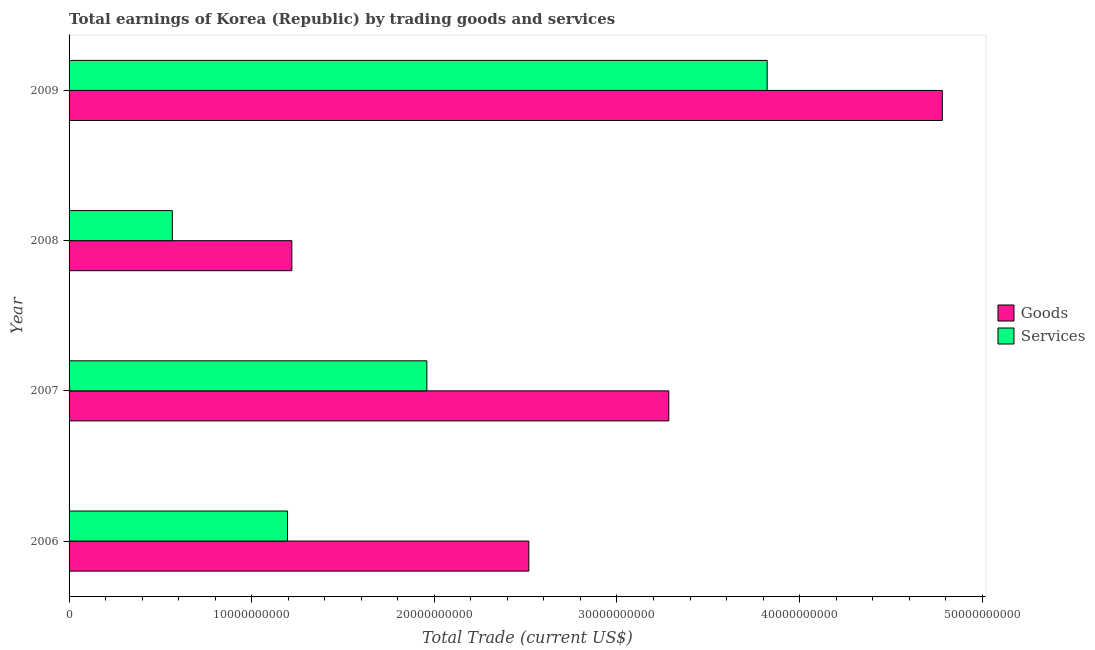How many different coloured bars are there?
Ensure brevity in your answer.  2. Are the number of bars per tick equal to the number of legend labels?
Your response must be concise. Yes. Are the number of bars on each tick of the Y-axis equal?
Keep it short and to the point. Yes. What is the label of the 3rd group of bars from the top?
Offer a very short reply. 2007. What is the amount earned by trading goods in 2009?
Offer a very short reply. 4.78e+1. Across all years, what is the maximum amount earned by trading goods?
Make the answer very short. 4.78e+1. Across all years, what is the minimum amount earned by trading goods?
Your answer should be very brief. 1.22e+1. In which year was the amount earned by trading services minimum?
Keep it short and to the point. 2008. What is the total amount earned by trading goods in the graph?
Your response must be concise. 1.18e+11. What is the difference between the amount earned by trading services in 2006 and that in 2009?
Make the answer very short. -2.63e+1. What is the difference between the amount earned by trading services in 2006 and the amount earned by trading goods in 2007?
Your answer should be compact. -2.09e+1. What is the average amount earned by trading services per year?
Your answer should be very brief. 1.89e+1. In the year 2007, what is the difference between the amount earned by trading services and amount earned by trading goods?
Offer a terse response. -1.32e+1. In how many years, is the amount earned by trading services greater than 18000000000 US$?
Provide a short and direct response. 2. What is the ratio of the amount earned by trading services in 2008 to that in 2009?
Make the answer very short. 0.15. What is the difference between the highest and the second highest amount earned by trading services?
Give a very brief answer. 1.86e+1. What is the difference between the highest and the lowest amount earned by trading services?
Your response must be concise. 3.26e+1. In how many years, is the amount earned by trading goods greater than the average amount earned by trading goods taken over all years?
Provide a short and direct response. 2. What does the 2nd bar from the top in 2006 represents?
Keep it short and to the point. Goods. What does the 2nd bar from the bottom in 2008 represents?
Offer a terse response. Services. How many bars are there?
Your answer should be compact. 8. Are all the bars in the graph horizontal?
Ensure brevity in your answer.  Yes. How many years are there in the graph?
Your answer should be compact. 4. Does the graph contain grids?
Make the answer very short. No. Where does the legend appear in the graph?
Offer a terse response. Center right. What is the title of the graph?
Your answer should be very brief. Total earnings of Korea (Republic) by trading goods and services. Does "Agricultural land" appear as one of the legend labels in the graph?
Make the answer very short. No. What is the label or title of the X-axis?
Your answer should be compact. Total Trade (current US$). What is the Total Trade (current US$) in Goods in 2006?
Make the answer very short. 2.52e+1. What is the Total Trade (current US$) of Services in 2006?
Provide a short and direct response. 1.20e+1. What is the Total Trade (current US$) of Goods in 2007?
Offer a terse response. 3.28e+1. What is the Total Trade (current US$) of Services in 2007?
Keep it short and to the point. 1.96e+1. What is the Total Trade (current US$) in Goods in 2008?
Your answer should be very brief. 1.22e+1. What is the Total Trade (current US$) of Services in 2008?
Make the answer very short. 5.65e+09. What is the Total Trade (current US$) of Goods in 2009?
Offer a terse response. 4.78e+1. What is the Total Trade (current US$) of Services in 2009?
Ensure brevity in your answer.  3.82e+1. Across all years, what is the maximum Total Trade (current US$) of Goods?
Your answer should be compact. 4.78e+1. Across all years, what is the maximum Total Trade (current US$) in Services?
Keep it short and to the point. 3.82e+1. Across all years, what is the minimum Total Trade (current US$) in Goods?
Your response must be concise. 1.22e+1. Across all years, what is the minimum Total Trade (current US$) in Services?
Provide a succinct answer. 5.65e+09. What is the total Total Trade (current US$) of Goods in the graph?
Your response must be concise. 1.18e+11. What is the total Total Trade (current US$) in Services in the graph?
Offer a terse response. 7.54e+1. What is the difference between the Total Trade (current US$) in Goods in 2006 and that in 2007?
Your answer should be very brief. -7.66e+09. What is the difference between the Total Trade (current US$) of Services in 2006 and that in 2007?
Keep it short and to the point. -7.63e+09. What is the difference between the Total Trade (current US$) of Goods in 2006 and that in 2008?
Keep it short and to the point. 1.30e+1. What is the difference between the Total Trade (current US$) in Services in 2006 and that in 2008?
Your answer should be compact. 6.31e+09. What is the difference between the Total Trade (current US$) in Goods in 2006 and that in 2009?
Make the answer very short. -2.26e+1. What is the difference between the Total Trade (current US$) of Services in 2006 and that in 2009?
Make the answer very short. -2.63e+1. What is the difference between the Total Trade (current US$) of Goods in 2007 and that in 2008?
Your response must be concise. 2.06e+1. What is the difference between the Total Trade (current US$) in Services in 2007 and that in 2008?
Give a very brief answer. 1.39e+1. What is the difference between the Total Trade (current US$) of Goods in 2007 and that in 2009?
Your answer should be compact. -1.50e+1. What is the difference between the Total Trade (current US$) of Services in 2007 and that in 2009?
Your answer should be compact. -1.86e+1. What is the difference between the Total Trade (current US$) of Goods in 2008 and that in 2009?
Give a very brief answer. -3.56e+1. What is the difference between the Total Trade (current US$) of Services in 2008 and that in 2009?
Provide a short and direct response. -3.26e+1. What is the difference between the Total Trade (current US$) in Goods in 2006 and the Total Trade (current US$) in Services in 2007?
Ensure brevity in your answer.  5.58e+09. What is the difference between the Total Trade (current US$) of Goods in 2006 and the Total Trade (current US$) of Services in 2008?
Give a very brief answer. 1.95e+1. What is the difference between the Total Trade (current US$) in Goods in 2006 and the Total Trade (current US$) in Services in 2009?
Offer a very short reply. -1.30e+1. What is the difference between the Total Trade (current US$) of Goods in 2007 and the Total Trade (current US$) of Services in 2008?
Your answer should be very brief. 2.72e+1. What is the difference between the Total Trade (current US$) in Goods in 2007 and the Total Trade (current US$) in Services in 2009?
Your answer should be compact. -5.39e+09. What is the difference between the Total Trade (current US$) in Goods in 2008 and the Total Trade (current US$) in Services in 2009?
Keep it short and to the point. -2.60e+1. What is the average Total Trade (current US$) of Goods per year?
Keep it short and to the point. 2.95e+1. What is the average Total Trade (current US$) of Services per year?
Keep it short and to the point. 1.89e+1. In the year 2006, what is the difference between the Total Trade (current US$) of Goods and Total Trade (current US$) of Services?
Offer a very short reply. 1.32e+1. In the year 2007, what is the difference between the Total Trade (current US$) of Goods and Total Trade (current US$) of Services?
Provide a succinct answer. 1.32e+1. In the year 2008, what is the difference between the Total Trade (current US$) in Goods and Total Trade (current US$) in Services?
Your answer should be compact. 6.54e+09. In the year 2009, what is the difference between the Total Trade (current US$) in Goods and Total Trade (current US$) in Services?
Keep it short and to the point. 9.59e+09. What is the ratio of the Total Trade (current US$) of Goods in 2006 to that in 2007?
Your answer should be very brief. 0.77. What is the ratio of the Total Trade (current US$) of Services in 2006 to that in 2007?
Make the answer very short. 0.61. What is the ratio of the Total Trade (current US$) of Goods in 2006 to that in 2008?
Your answer should be very brief. 2.06. What is the ratio of the Total Trade (current US$) of Services in 2006 to that in 2008?
Give a very brief answer. 2.12. What is the ratio of the Total Trade (current US$) in Goods in 2006 to that in 2009?
Keep it short and to the point. 0.53. What is the ratio of the Total Trade (current US$) of Services in 2006 to that in 2009?
Your answer should be very brief. 0.31. What is the ratio of the Total Trade (current US$) of Goods in 2007 to that in 2008?
Provide a succinct answer. 2.69. What is the ratio of the Total Trade (current US$) of Services in 2007 to that in 2008?
Your answer should be very brief. 3.46. What is the ratio of the Total Trade (current US$) of Goods in 2007 to that in 2009?
Your response must be concise. 0.69. What is the ratio of the Total Trade (current US$) in Services in 2007 to that in 2009?
Offer a terse response. 0.51. What is the ratio of the Total Trade (current US$) in Goods in 2008 to that in 2009?
Make the answer very short. 0.26. What is the ratio of the Total Trade (current US$) in Services in 2008 to that in 2009?
Offer a terse response. 0.15. What is the difference between the highest and the second highest Total Trade (current US$) in Goods?
Your response must be concise. 1.50e+1. What is the difference between the highest and the second highest Total Trade (current US$) in Services?
Make the answer very short. 1.86e+1. What is the difference between the highest and the lowest Total Trade (current US$) in Goods?
Ensure brevity in your answer.  3.56e+1. What is the difference between the highest and the lowest Total Trade (current US$) of Services?
Offer a terse response. 3.26e+1. 